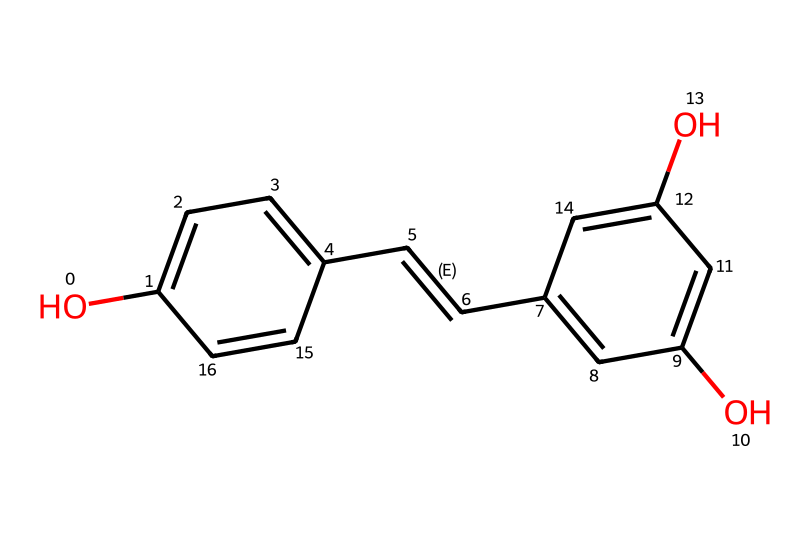What is the IUPAC name of this compound? The SMILES representation indicates that the compound consists of two aromatic rings connected by a double bond and has hydroxyl (–OH) groups. The IUPAC name for this structure is 3,5,4'-trihydroxy-trans-stilbene.
Answer: 3,5,4'-trihydroxy-trans-stilbene How many hydroxyl groups are present? By analyzing the structure, we can see there are three hydroxyl (–OH) groups attached to the aromatic rings.
Answer: three What type of bonds connect the carbon atoms? The structure includes single bonds (in the aromatic rings and the –OH groups) and a double bond between two carbon atoms in the stilbene structure.
Answer: single and double bonds Which functional group contributes to its antioxidant properties? The hydroxyl groups (–OH) are known for their ability to donate hydrogen atoms or electrons, making them crucial for the antioxidant activity of the compound.
Answer: hydroxyl groups What is the significance of the oligomeric structure in antioxidants? The presence of multiple hydroxyl groups and aromatic rings allows for better stabilization of free radicals and enhances the antioxidant capacity. This increases the compound's effectiveness in neutralizing oxidative stress.
Answer: enhances antioxidant capacity How does flexibility in the carbon chain affect the antioxidant activity? The presence of a double bond in the chain can provide some conformational flexibility, allowing the compound to interact more effectively with free radicals and thus improve its antioxidant action.
Answer: improves interaction 